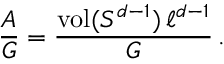<formula> <loc_0><loc_0><loc_500><loc_500>\frac { A } { G } = \frac { v o l ( S ^ { d - 1 } ) \, \ell ^ { d - 1 } } { G } \, .</formula> 